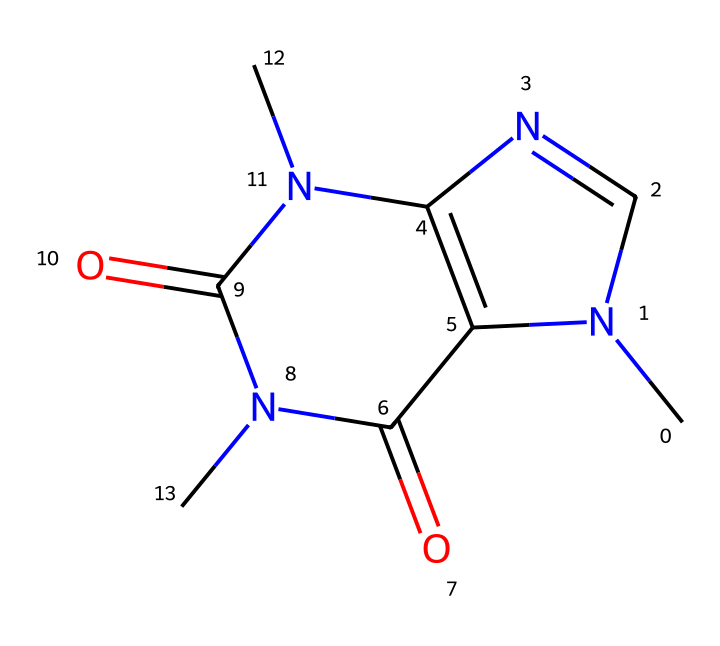What is the molecular formula of this chemical? To determine the molecular formula, count the number of each type of atom present in the given SMILES: C (carbon), N (nitrogen), O (oxygen). The structure shows 8 carbons (C), 10 hydrogens (H), 4 nitrogens (N), and 2 oxygens (O). Therefore, the molecular formula is C8H10N4O2.
Answer: C8H10N4O2 How many nitrogen atoms are present in the structure? Inspecting the SMILES representation, we see there are four occurrences of the nitrogen atom (N). Counting these gives a total of 4 nitrogen atoms in the structure.
Answer: 4 What type of functional groups are present in this compound? Analyzing the structure, we can identify the presence of two carbonyl groups (C=O) which indicate the presence of amides due to the nitrogen atoms connected to these carbonyls. No other functional groups are observable in the given SMILES.
Answer: carbonyl, amide Which part of this chemical structure contributes to its stimulant properties? The stimulant properties of caffeine are attributed to its methyl groups attached to nitrogen atoms in the structure, which enhances its ability to cross the blood-brain barrier and compete with adenosine.
Answer: methyl groups What is the role of the ring structure in caffeine? The ring structure in caffeine comprises linked carbon and nitrogen atoms, forming a bicyclic arrangement that is crucial for receptor binding in biological systems. This rigid structure influences how caffeine interacts with neurotransmitter receptors, leading to its stimulant effects.
Answer: receptor binding How many rings are present in the structure of caffeine? In observing the structure, it is clear that there are two interconnected rings formed by the nitrogen and carbon atoms in the structure, characteristic of its purine structure.
Answer: 2 